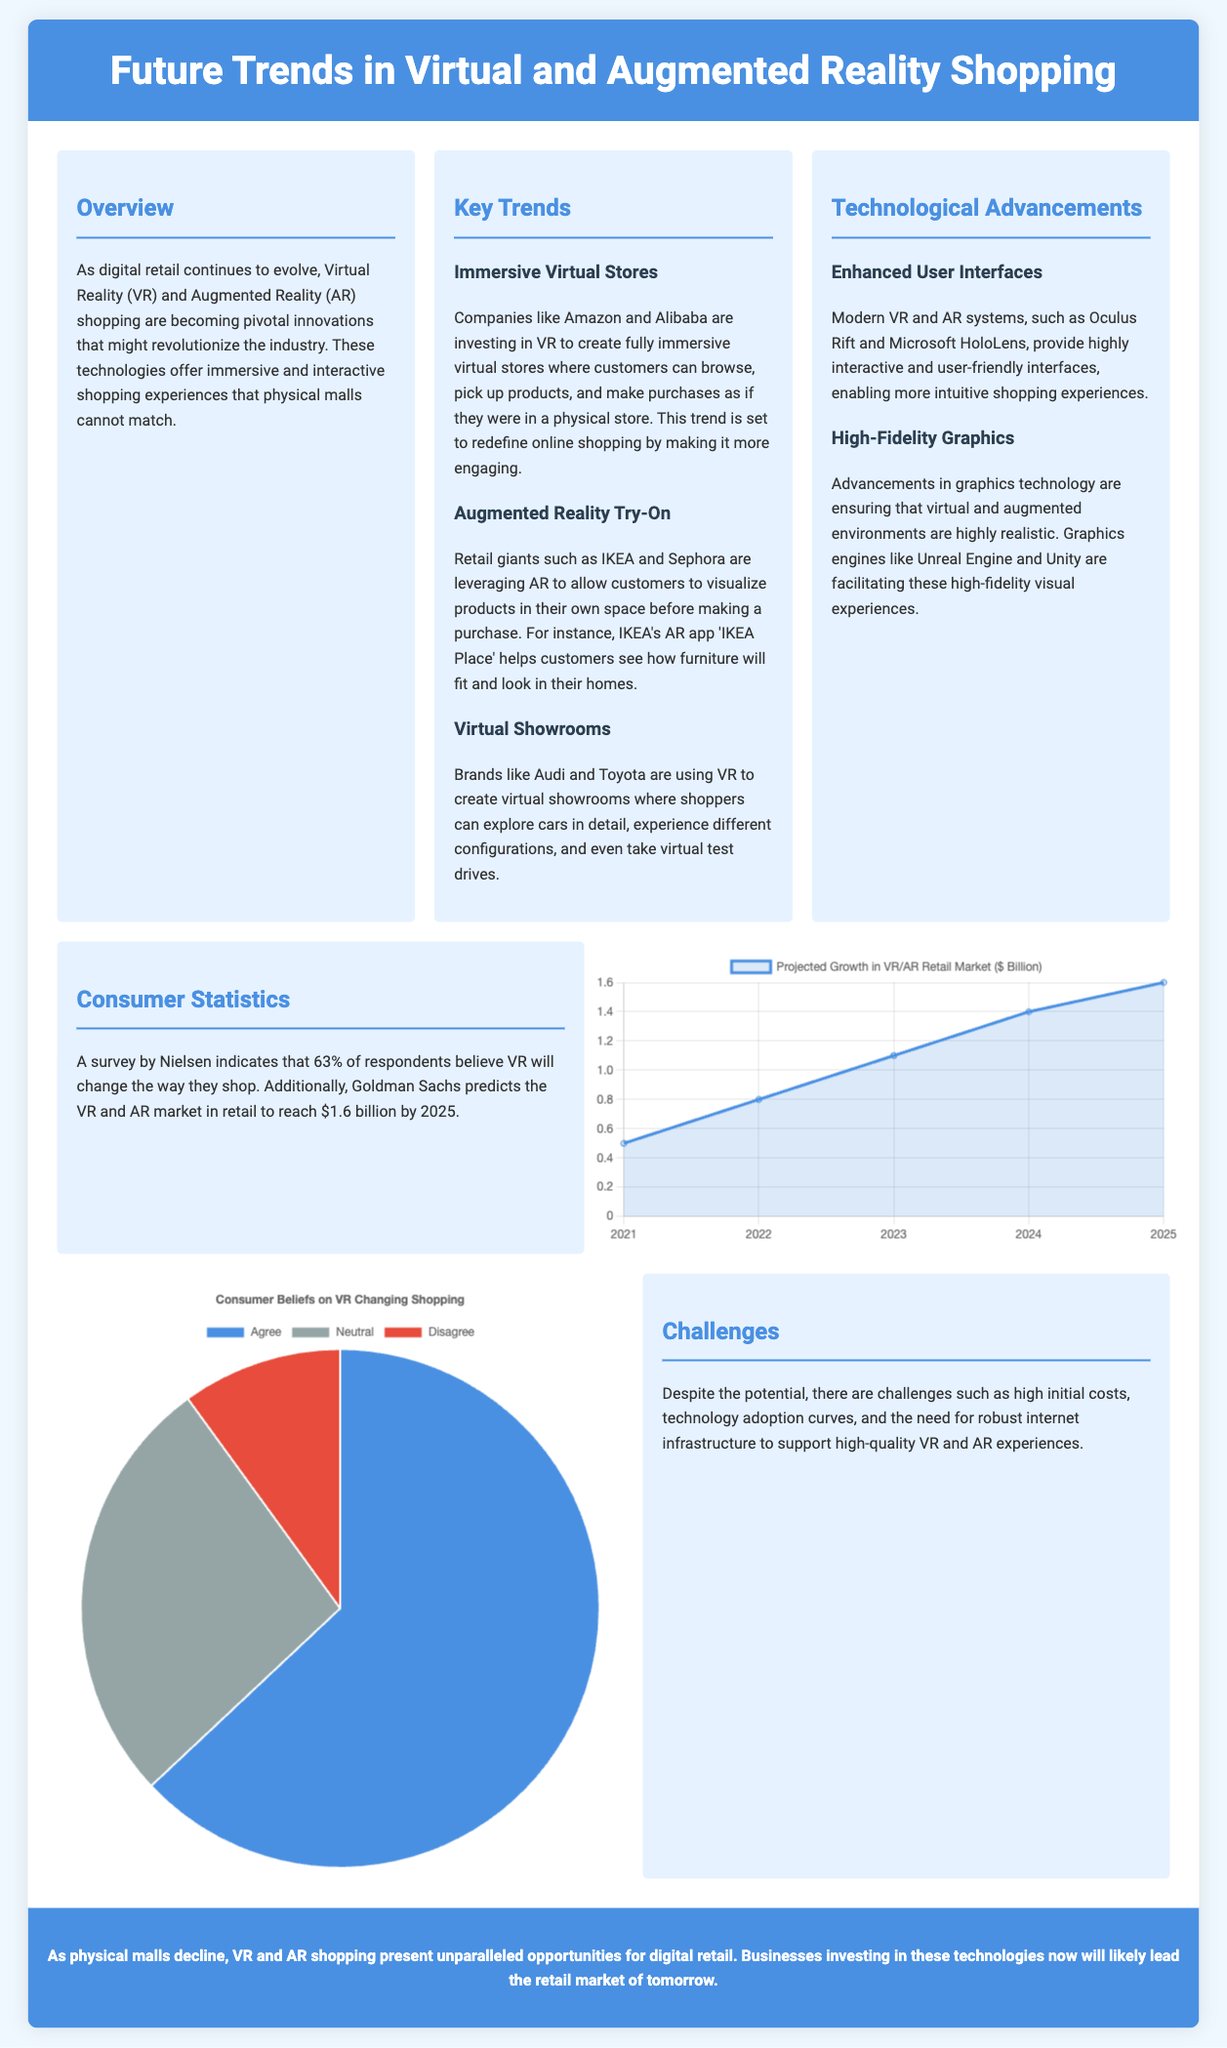What is the projected growth of the VR/AR retail market in 2025? The projected growth of the VR/AR retail market in 2025 is indicated in the growth chart as $1.6 billion.
Answer: $1.6 billion Which brand is mentioned as using AR for furniture visualization? IKEA is specifically mentioned for using AR to help customers see how furniture will fit in their homes.
Answer: IKEA What percentage of respondents believe VR will change the way they shop? According to the consumer statistics section, 63% of respondents believe VR will change their shopping experience.
Answer: 63% What is a key challenge mentioned in the document regarding VR and AR shopping? The challenges include high initial costs, technology adoption curves, and the need for robust internet infrastructure.
Answer: High initial costs Which technology is suggested as providing enhanced user interfaces for VR and AR systems? The document mentions Oculus Rift and Microsoft HoloLens as modern systems providing enhanced user interfaces.
Answer: Oculus Rift and Microsoft HoloLens In which year does the growth chart start showing data? The growth chart begins with the year 2021 as the initial data point.
Answer: 2021 What type of chart is used to represent consumer beliefs on VR changing shopping? A pie chart is utilized to illustrate consumer beliefs regarding VR's impact on shopping.
Answer: Pie chart What is the color code for the "Disagree" segment in the belief chart? The color code for the "Disagree" segment of the belief chart is represented as red.
Answer: Red What is the purpose of the immersive virtual stores trend? The purpose is to redefine online shopping by creating an engaging, immersive experience for customers.
Answer: Redefine online shopping 